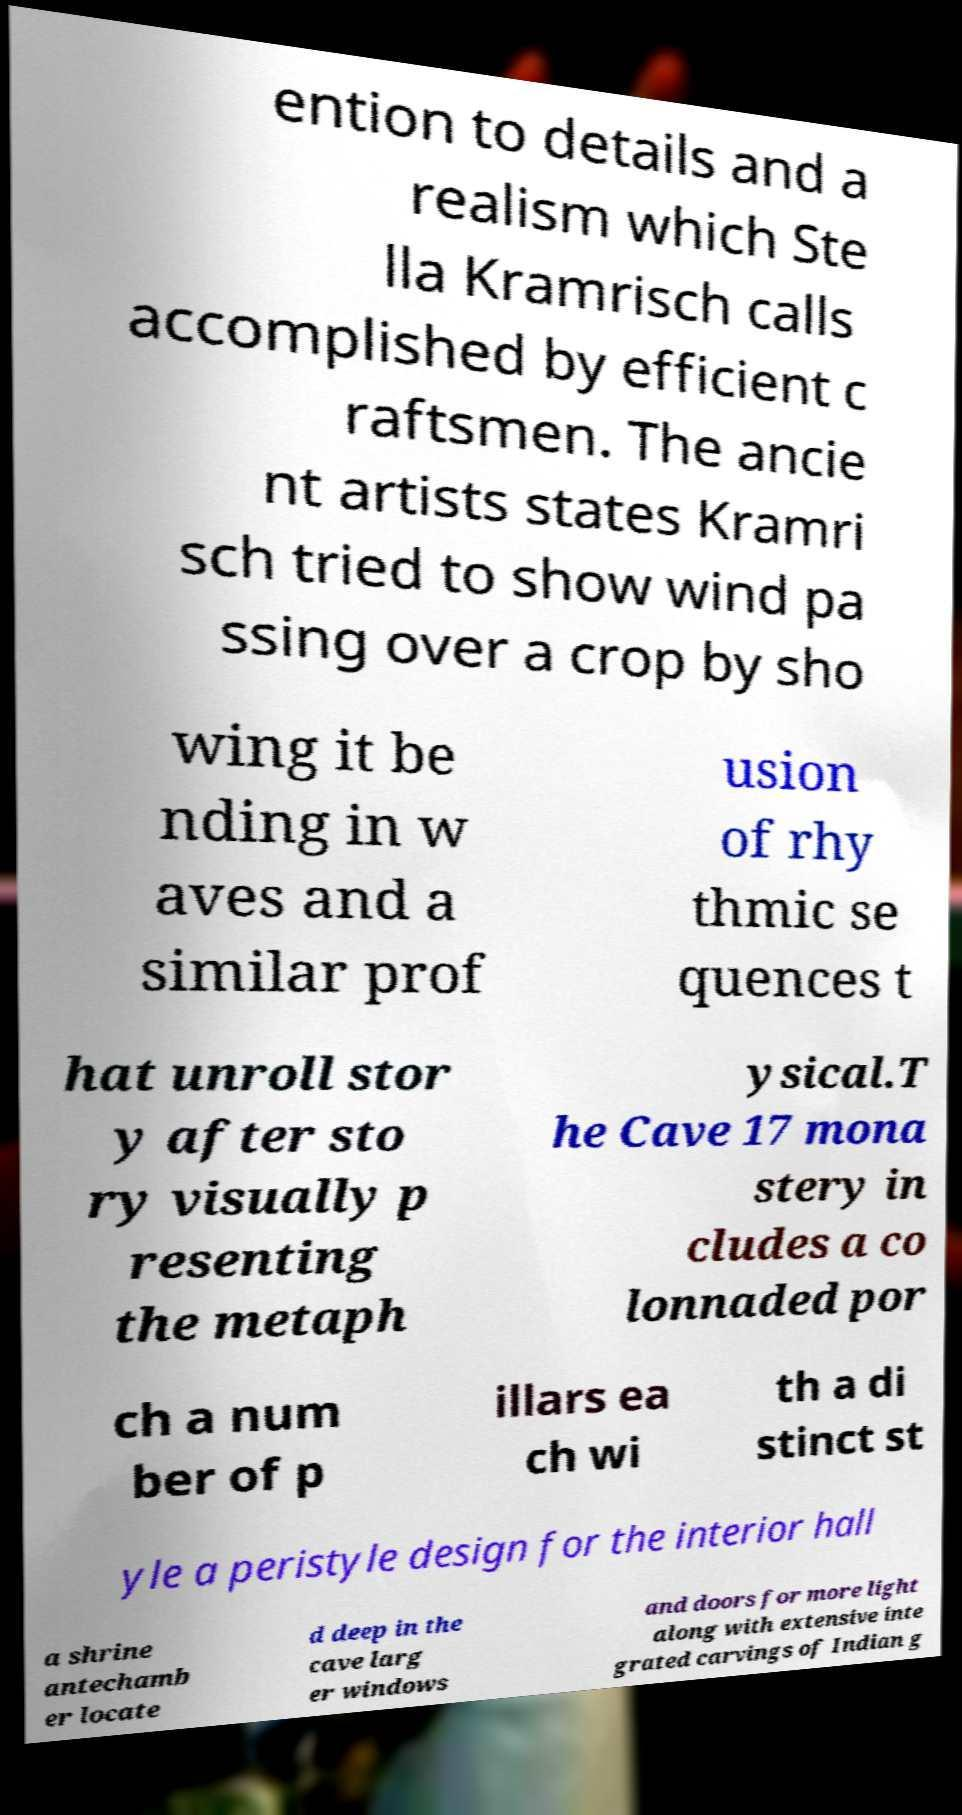Can you read and provide the text displayed in the image?This photo seems to have some interesting text. Can you extract and type it out for me? ention to details and a realism which Ste lla Kramrisch calls accomplished by efficient c raftsmen. The ancie nt artists states Kramri sch tried to show wind pa ssing over a crop by sho wing it be nding in w aves and a similar prof usion of rhy thmic se quences t hat unroll stor y after sto ry visually p resenting the metaph ysical.T he Cave 17 mona stery in cludes a co lonnaded por ch a num ber of p illars ea ch wi th a di stinct st yle a peristyle design for the interior hall a shrine antechamb er locate d deep in the cave larg er windows and doors for more light along with extensive inte grated carvings of Indian g 